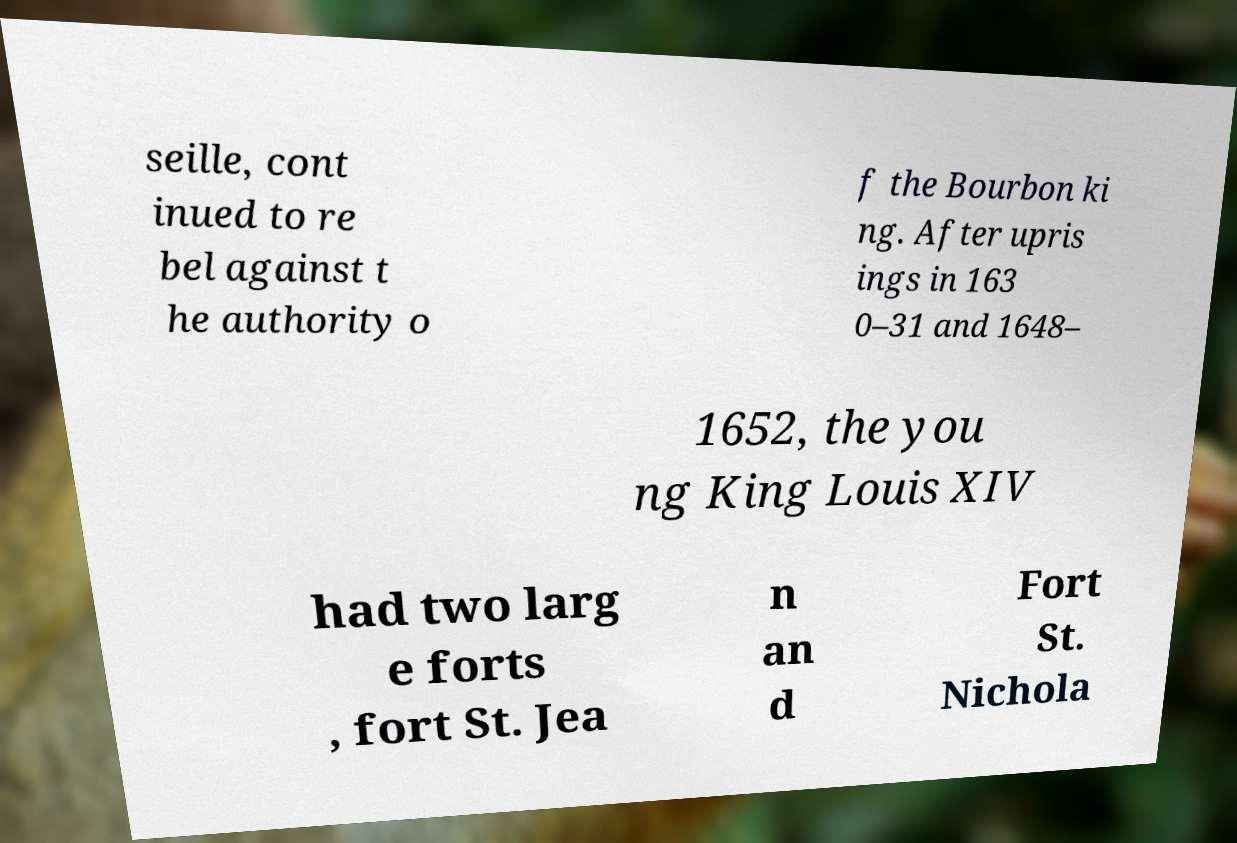Please identify and transcribe the text found in this image. seille, cont inued to re bel against t he authority o f the Bourbon ki ng. After upris ings in 163 0–31 and 1648– 1652, the you ng King Louis XIV had two larg e forts , fort St. Jea n an d Fort St. Nichola 